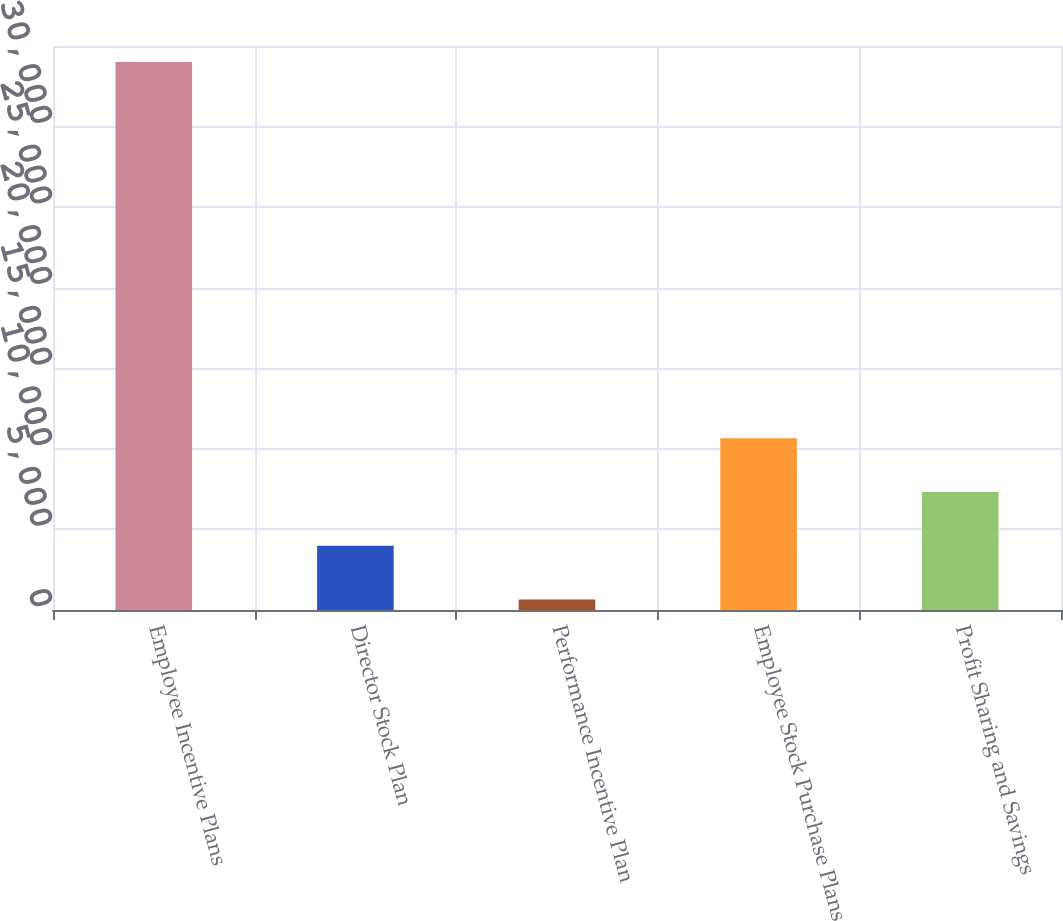Convert chart. <chart><loc_0><loc_0><loc_500><loc_500><bar_chart><fcel>Employee Incentive Plans<fcel>Director Stock Plan<fcel>Performance Incentive Plan<fcel>Employee Stock Purchase Plans<fcel>Profit Sharing and Savings<nl><fcel>34000<fcel>3985<fcel>650<fcel>10655<fcel>7320<nl></chart> 